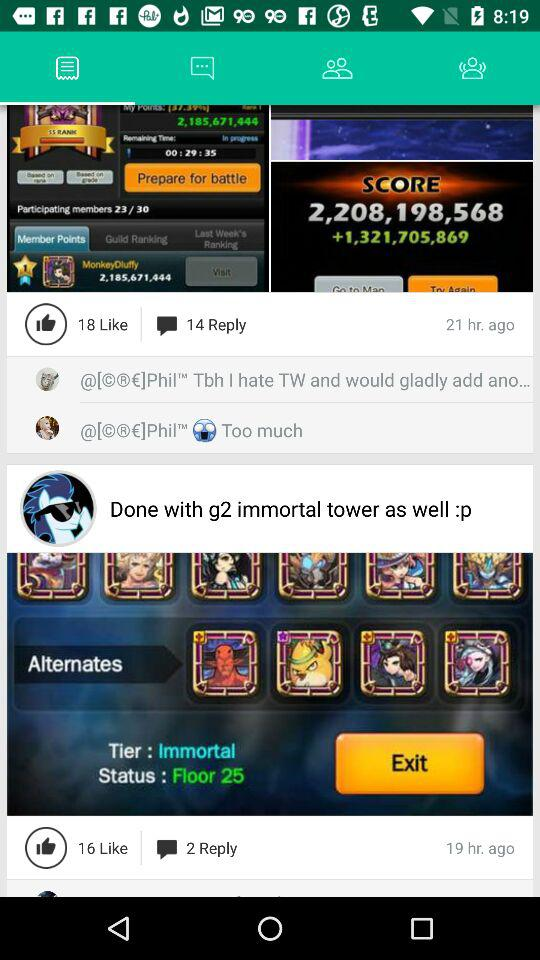How many more likes does the first post have than the second post?
Answer the question using a single word or phrase. 2 